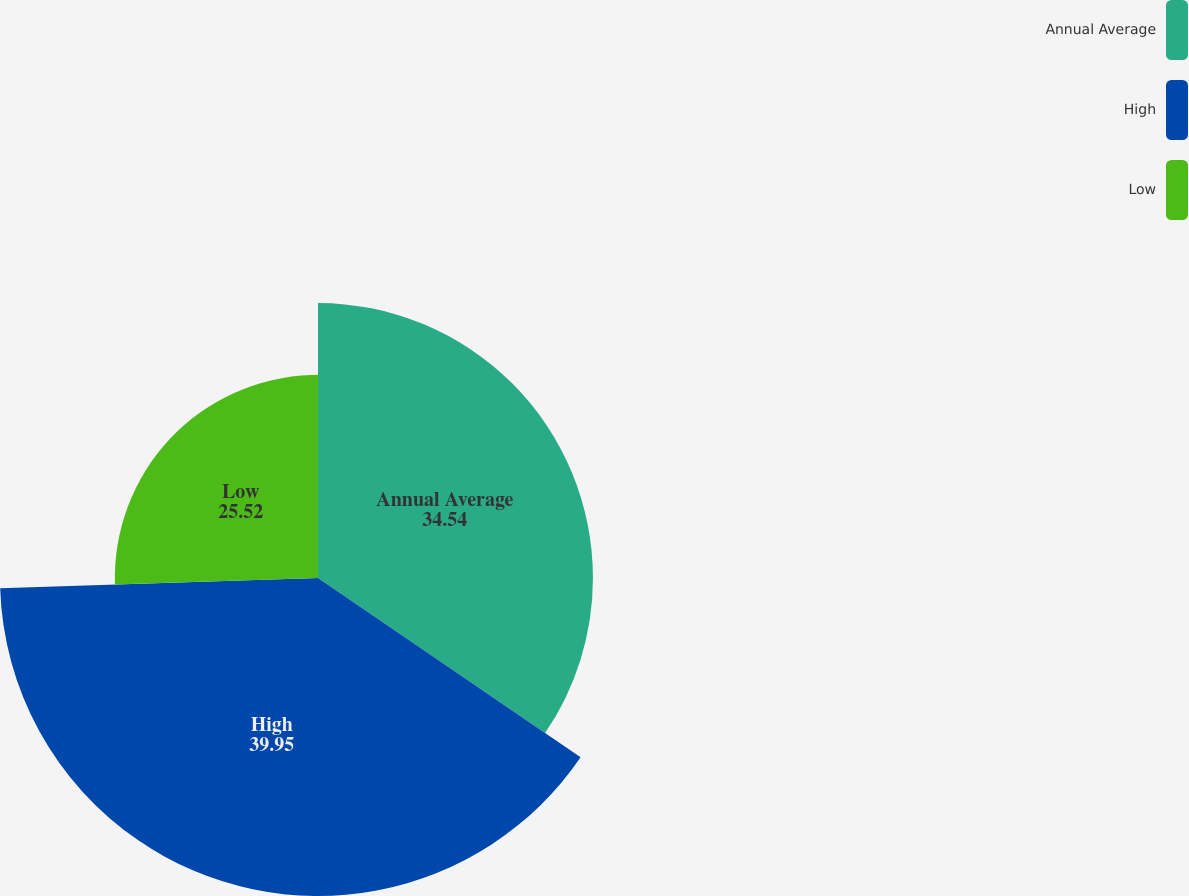Convert chart. <chart><loc_0><loc_0><loc_500><loc_500><pie_chart><fcel>Annual Average<fcel>High<fcel>Low<nl><fcel>34.54%<fcel>39.95%<fcel>25.52%<nl></chart> 